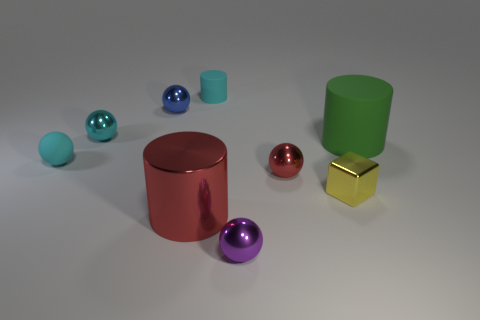Subtract all tiny purple metal spheres. How many spheres are left? 4 Subtract all purple balls. How many balls are left? 4 Subtract 1 balls. How many balls are left? 4 Subtract all brown spheres. Subtract all green cylinders. How many spheres are left? 5 Add 1 tiny metal balls. How many objects exist? 10 Subtract all cylinders. How many objects are left? 6 Add 9 yellow metallic things. How many yellow metallic things are left? 10 Add 3 tiny gray matte blocks. How many tiny gray matte blocks exist? 3 Subtract 1 purple balls. How many objects are left? 8 Subtract all red metal objects. Subtract all green matte cylinders. How many objects are left? 6 